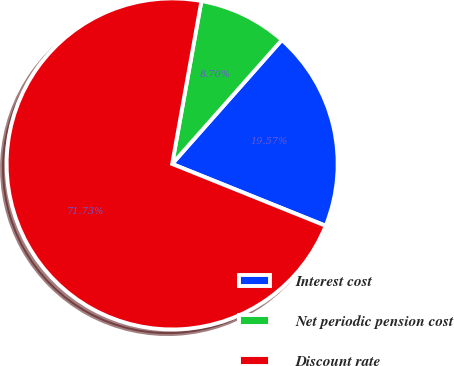Convert chart. <chart><loc_0><loc_0><loc_500><loc_500><pie_chart><fcel>Interest cost<fcel>Net periodic pension cost<fcel>Discount rate<nl><fcel>19.57%<fcel>8.7%<fcel>71.74%<nl></chart> 